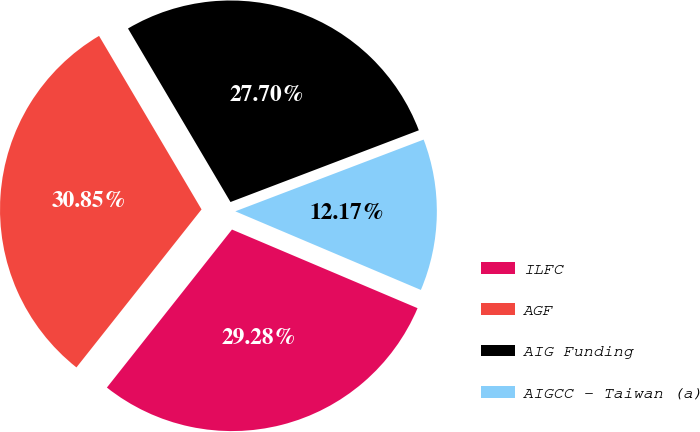Convert chart to OTSL. <chart><loc_0><loc_0><loc_500><loc_500><pie_chart><fcel>ILFC<fcel>AGF<fcel>AIG Funding<fcel>AIGCC - Taiwan (a)<nl><fcel>29.28%<fcel>30.85%<fcel>27.7%<fcel>12.17%<nl></chart> 